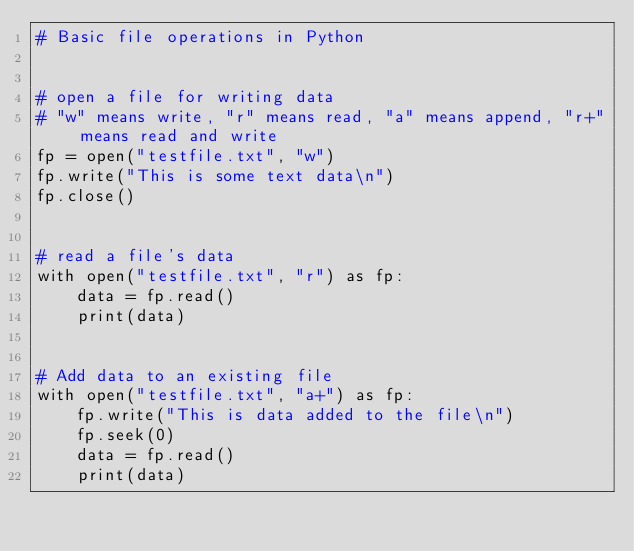Convert code to text. <code><loc_0><loc_0><loc_500><loc_500><_Python_># Basic file operations in Python


# open a file for writing data
# "w" means write, "r" means read, "a" means append, "r+" means read and write
fp = open("testfile.txt", "w")
fp.write("This is some text data\n")
fp.close()


# read a file's data
with open("testfile.txt", "r") as fp:
    data = fp.read()
    print(data)


# Add data to an existing file
with open("testfile.txt", "a+") as fp:
    fp.write("This is data added to the file\n")
    fp.seek(0)
    data = fp.read()
    print(data)
</code> 